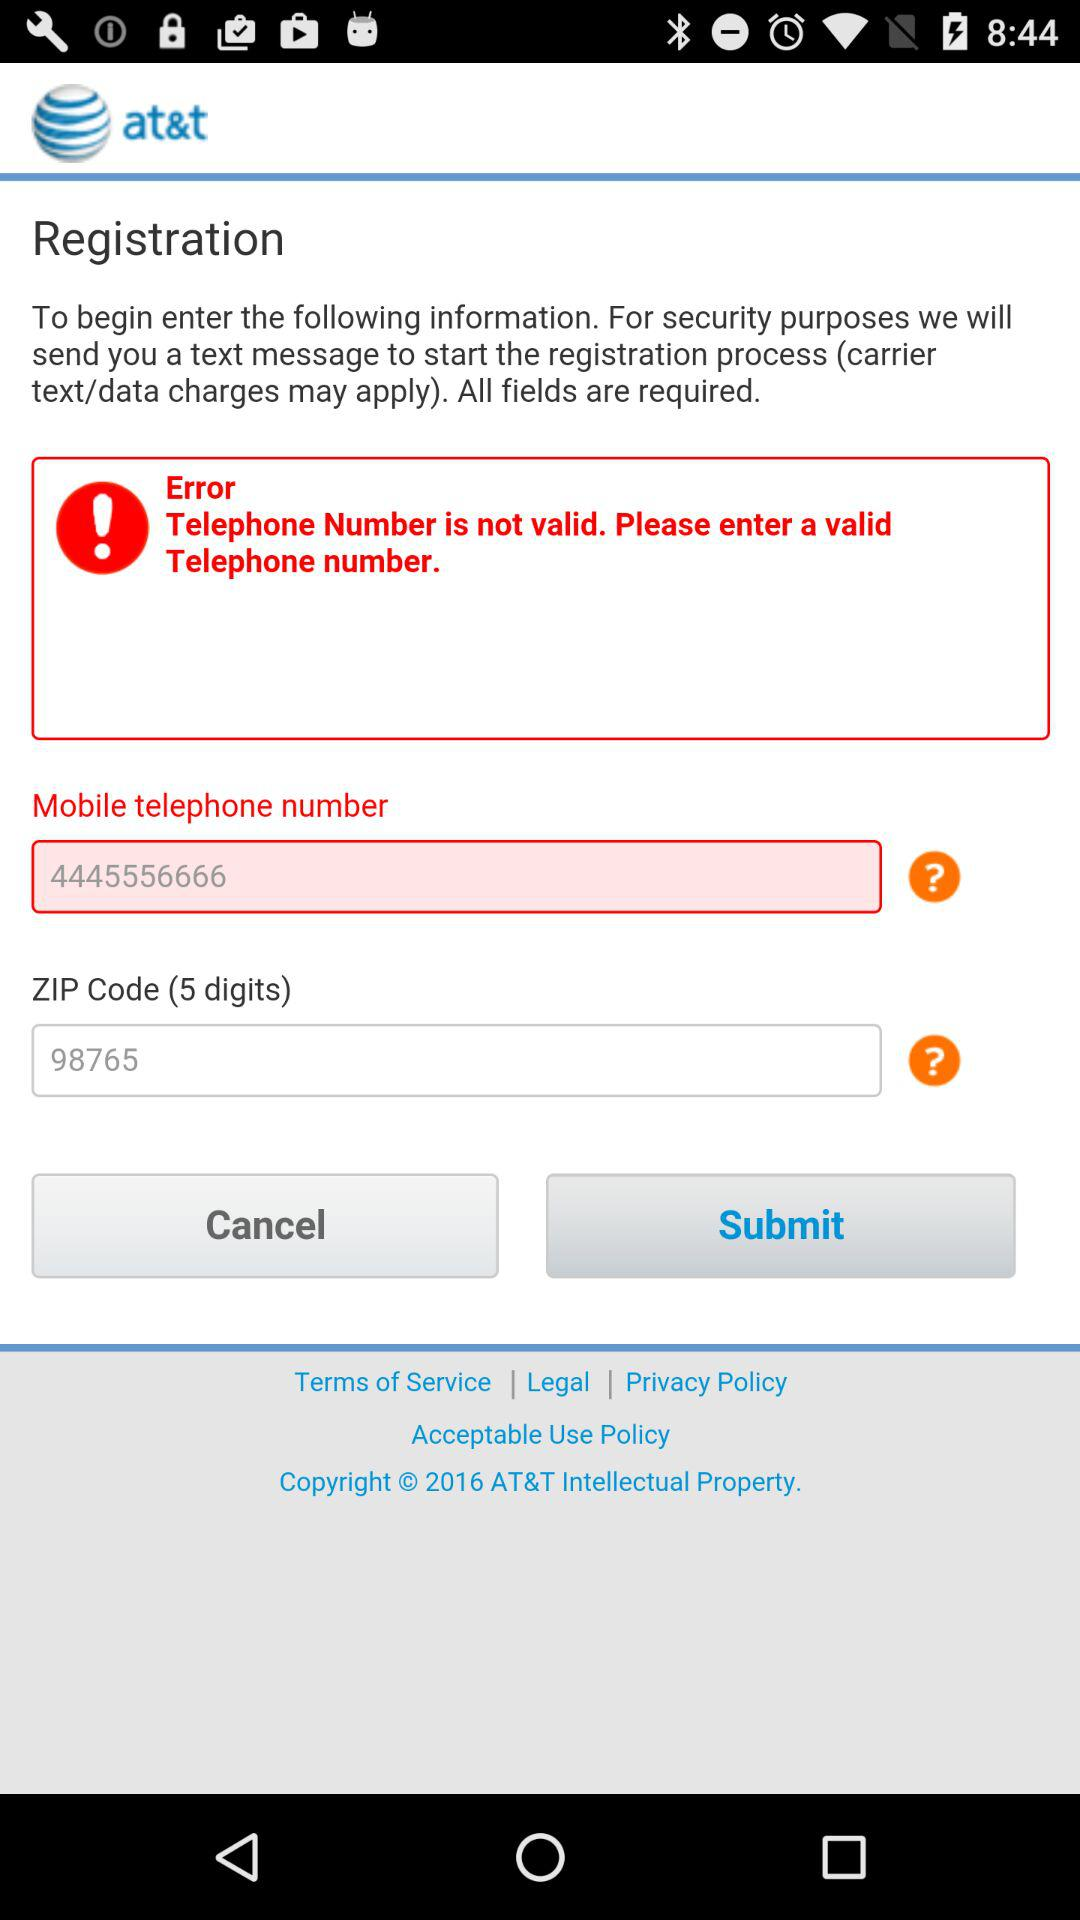What is the given telephone number? The given telephone number is 4445556666. 